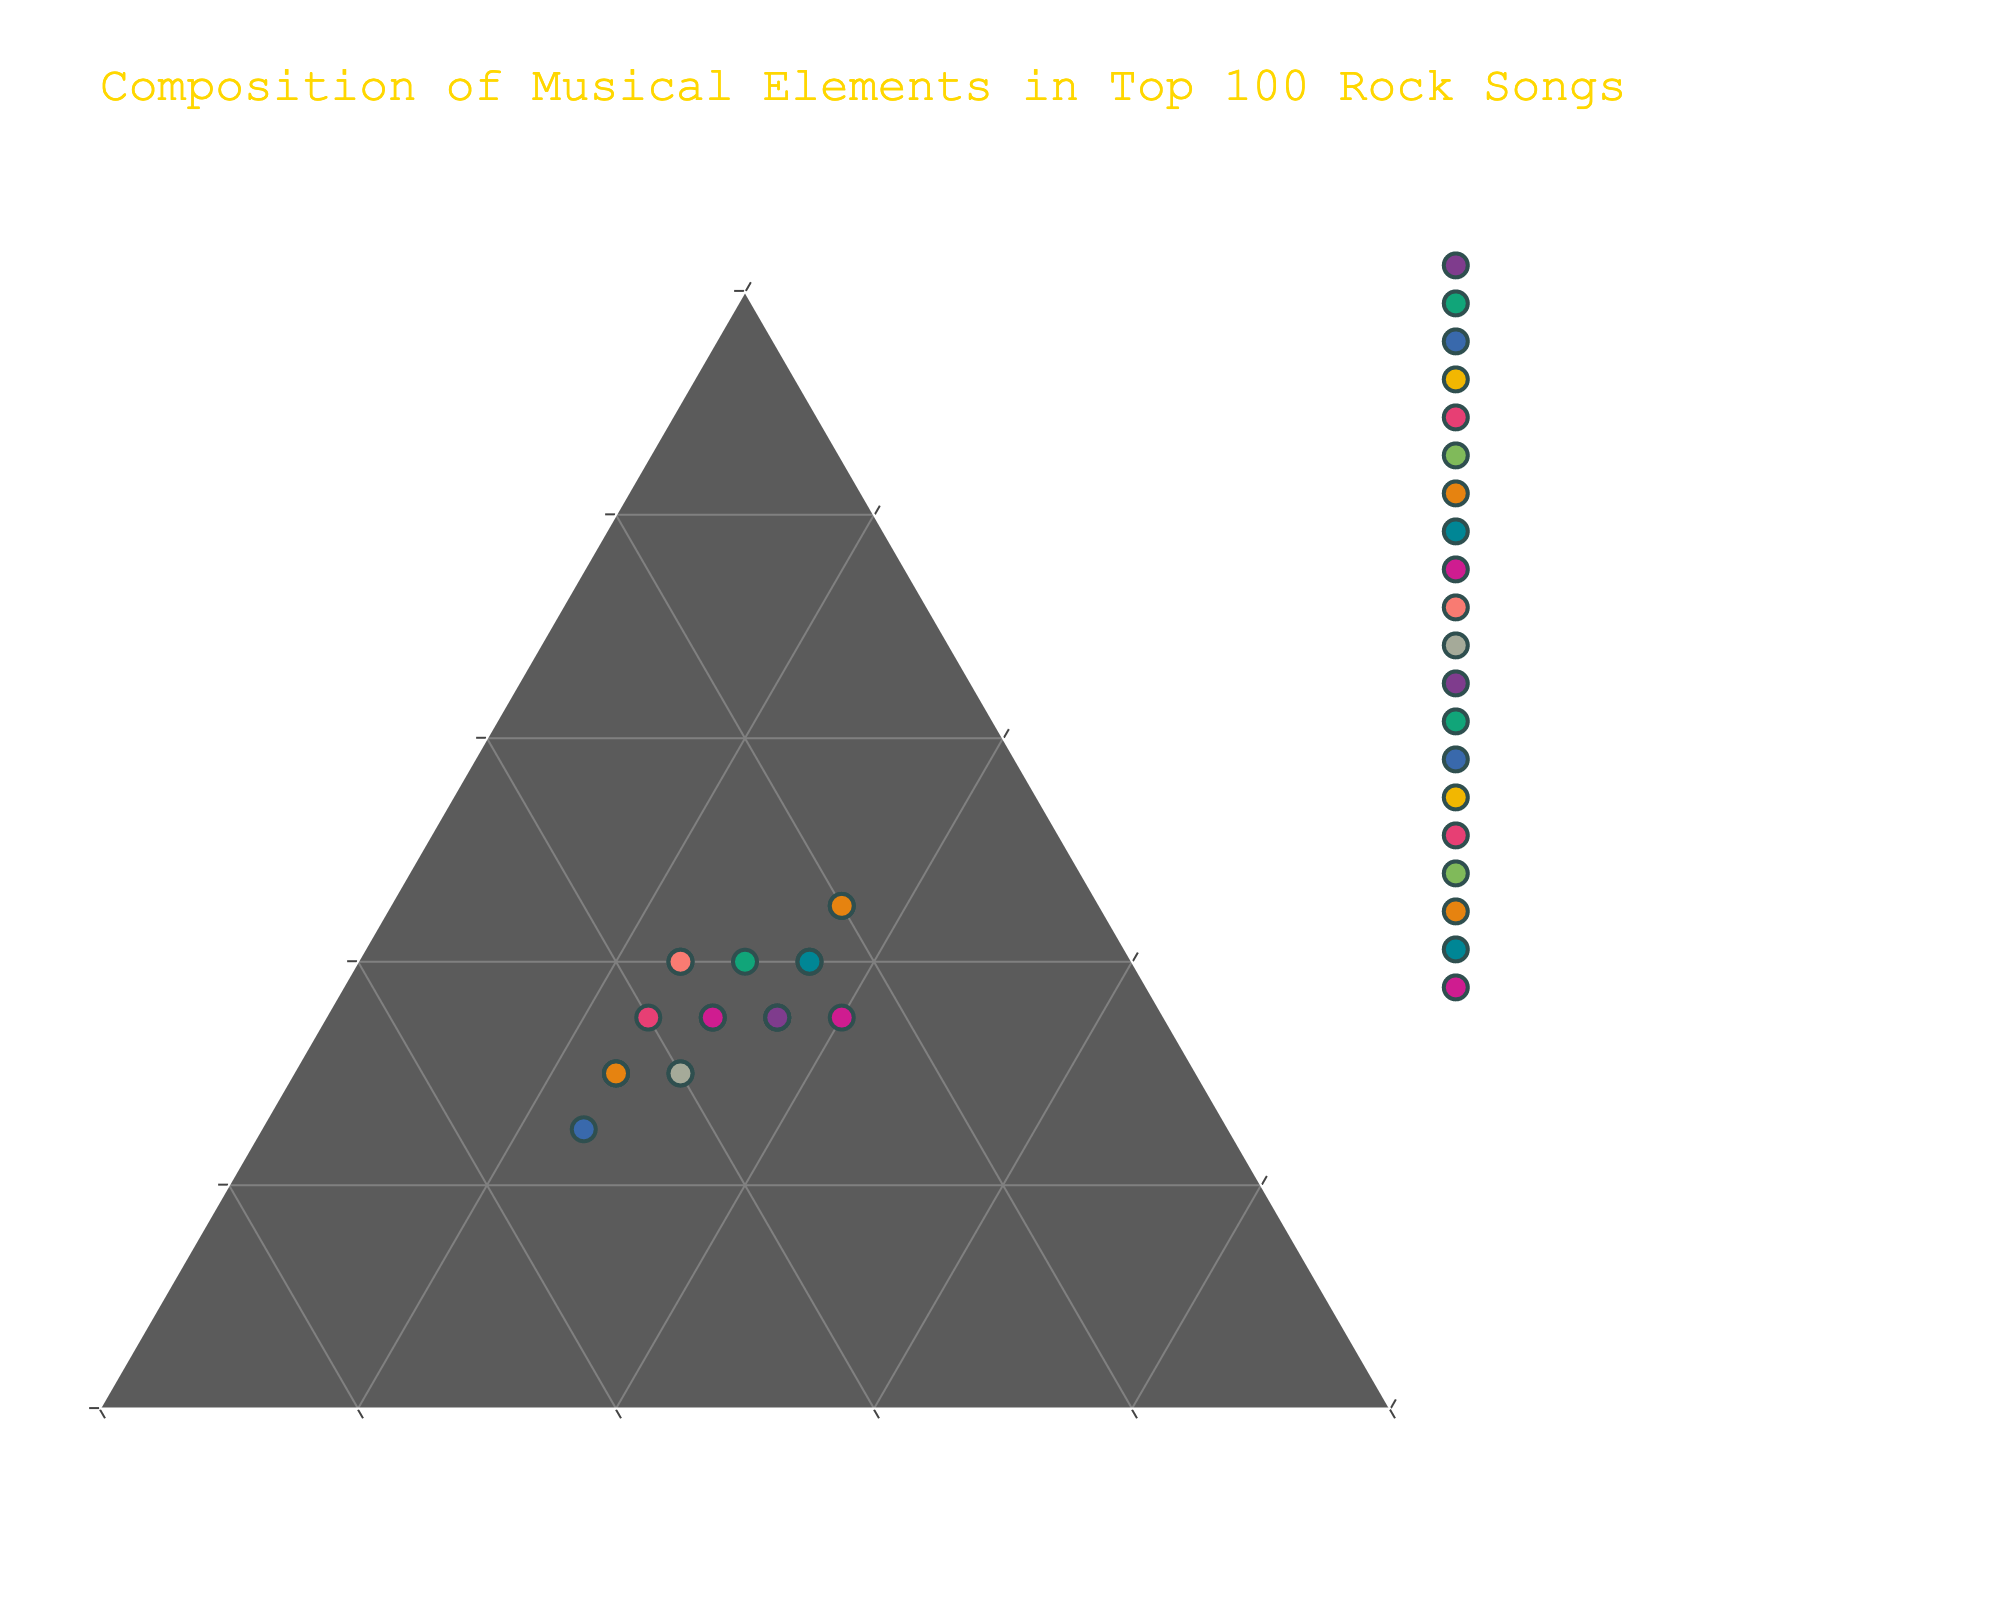What is the title of the plot? The title is prominently displayed at the top of the plot in a larger font and a different color. It helps in understanding the main subject of the visualization.
Answer: Composition of Musical Elements in Top 100 Rock Songs How many songs have Melody as their highest percentage? To determine this, I locate the songs where the Melody value is greater than both the Rhythm and Harmony values. According to the data, these songs are "Stairway to Heaven", "Bohemian Rhapsody", "Imagine", "Sympathy for the Devil", "Wish You Were Here", and "Sweet Child o' Mine".
Answer: 6 Which song has the highest Rhythm percentage? To find this, I compare the Rhythm values of all songs. The song with the highest Rhythm percentage is "Back in Black" with a value of 50%.
Answer: Back in Black What is the combined percentage of Rhythm and Harmony for "Smoke on the Water"? I add the Rhythm and Harmony values for "Smoke on the Water". Rhythm: 45, Harmony: 25. Thus, 45 + 25 = 70.
Answer: 70 How does "Comfortably Numb" compare to "Hotel California" in terms of Harmony percentage? I locate both songs' Harmony values. "Comfortably Numb" has a Harmony value of 40, while "Hotel California" has a Harmony value of 35. Thus, "Comfortably Numb" has 5% more Harmony.
Answer: 5% more Which song has an equal percentage of Melody and Harmony? I look for songs where the Melody and Harmony values are the same. "Comfortably Numb", "Purple Rain", "Hotel California", "Wish You Were Here" and "Light My Fire" fit this criteria with both values set at 35%.
Answer: Comfortably Numb, Purple Rain, Hotel California, Wish You Were Here, Light My Fire What is the average percentage of Melody across all songs? To find this, I sum the Melody values of all songs and divide by the number of songs (20). The total Melody value is 785. So, 785 ÷ 20 = 39.25.
Answer: 39.25 In which region (high Melody, high Rhythm, high Harmony) are most songs located? By observing the general clustering of data points, I determine that most songs are near the high Melody region as there are more data points towards the apex representing high Melody.
Answer: High Melody What is the percentage difference between Melody and Harmony for "Smells Like Teen Spirit"? I subtract the Harmony value from the Melody value for "Smells Like Teen Spirit". Melody: 30, Harmony: 25. Hence, 30 - 25 = 5.
Answer: 5 Which song has the most balanced composition of Melody, Rhythm, and Harmony? By identifying the song with values closest to being equal among the three categories. "Jimi Hendrix - All Along the Watchtower" has Melody: 35, Rhythm: 35, and Harmony: 30, making it the most balanced.
Answer: Jimi Hendrix - All Along the Watchtower 